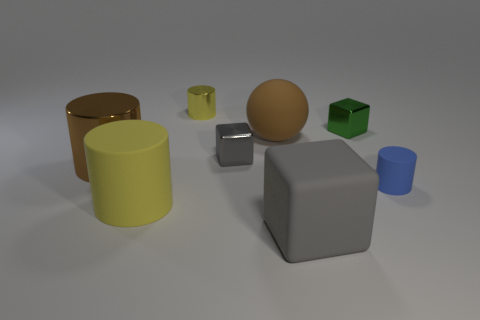What number of other things are the same shape as the small gray object?
Give a very brief answer. 2. What color is the shiny cylinder that is the same size as the blue matte cylinder?
Provide a succinct answer. Yellow. Are there fewer small green things that are in front of the small green metal block than tiny metallic things that are left of the matte cube?
Keep it short and to the point. Yes. There is a tiny shiny block on the right side of the large rubber thing that is behind the brown cylinder; what number of blocks are to the left of it?
Offer a very short reply. 2. There is a rubber object that is the same shape as the green shiny object; what size is it?
Keep it short and to the point. Large. Are there fewer big gray blocks that are on the left side of the large yellow object than brown balls?
Offer a very short reply. Yes. Is the shape of the small green shiny thing the same as the big gray object?
Make the answer very short. Yes. What color is the other big matte thing that is the same shape as the blue rubber thing?
Keep it short and to the point. Yellow. What number of large rubber things are the same color as the large metal thing?
Offer a terse response. 1. What number of objects are tiny things that are in front of the tiny yellow shiny cylinder or big yellow things?
Provide a succinct answer. 4. 